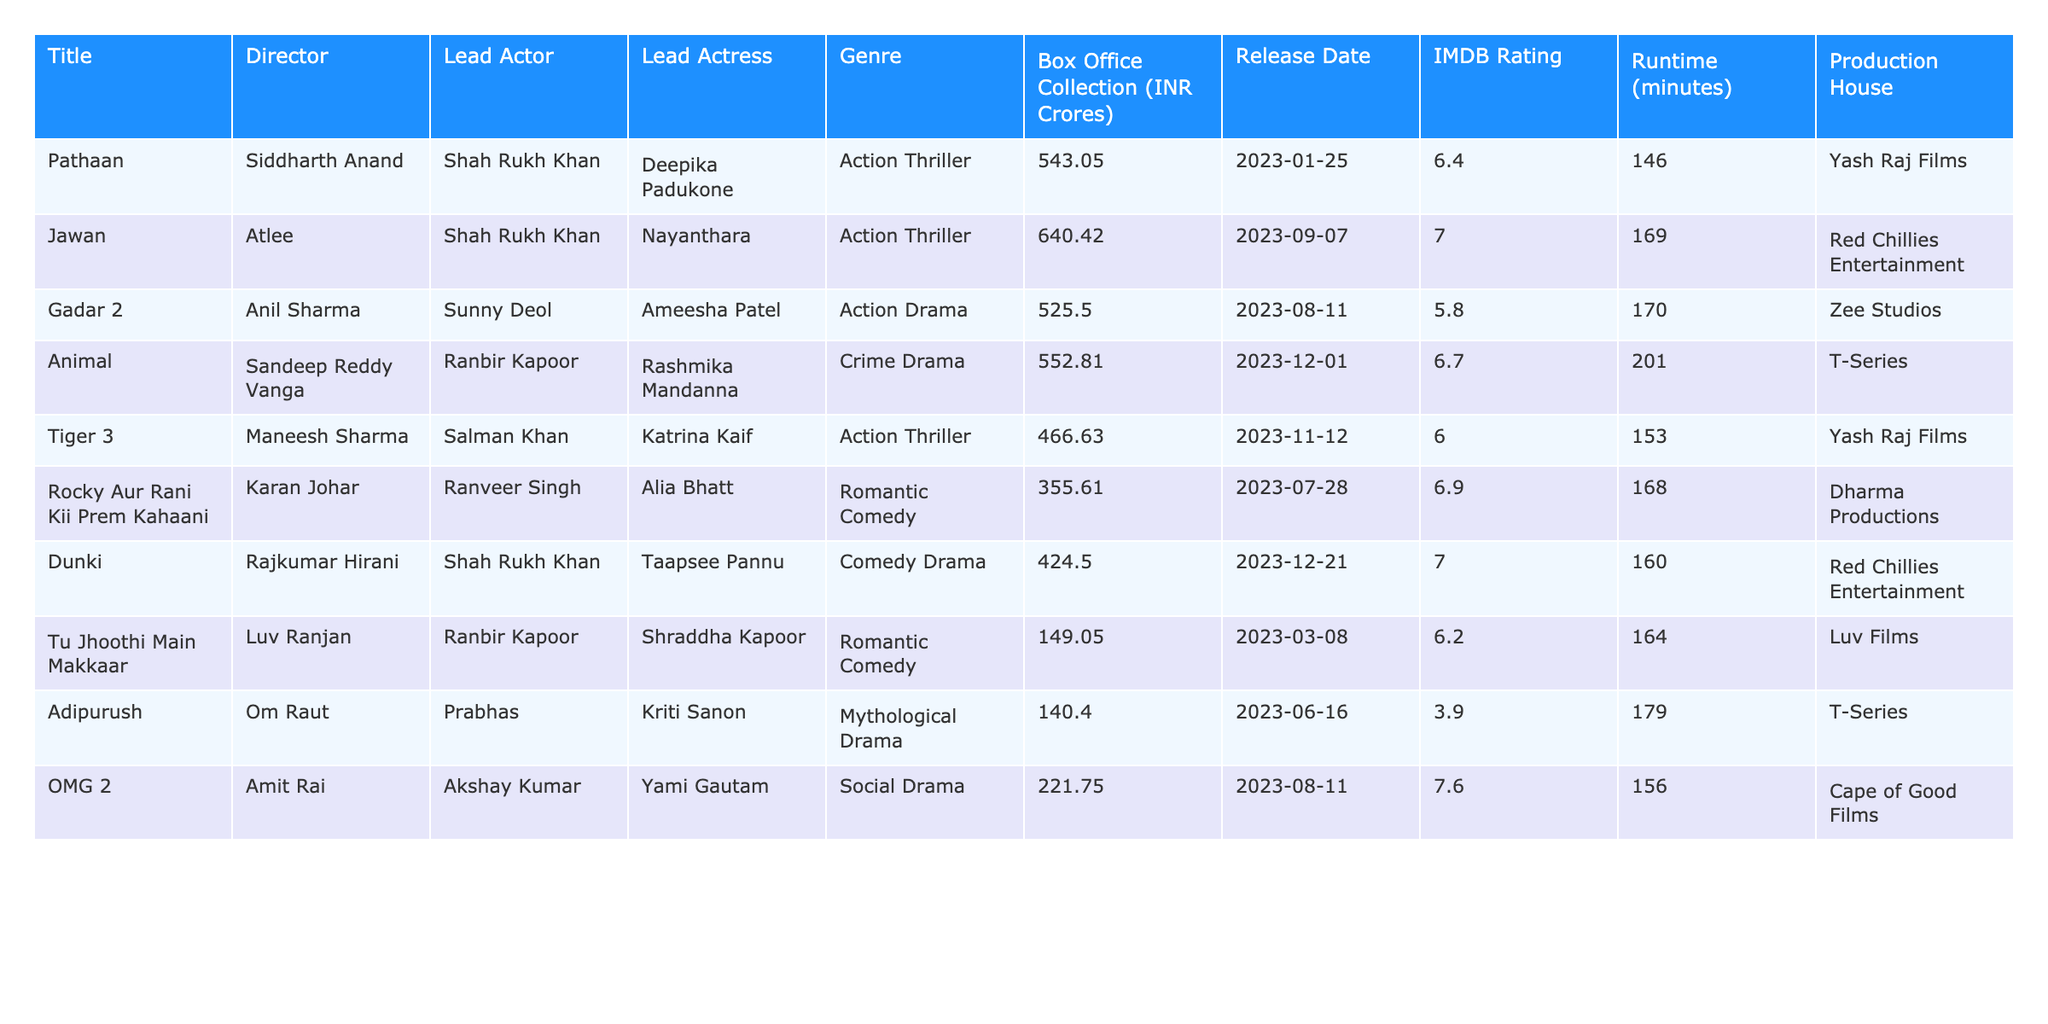What is the highest-grossing Bollywood film of the past year? The table shows "Jawan" as the film with the highest Box Office Collection of 640.42 INR Crores.
Answer: Jawan Which film features Shah Rukh Khan and Deepika Padukone? The film "Pathaan" features Shah Rukh Khan as the lead actor and Deepika Padukone as the lead actress.
Answer: Pathaan What is the IMDB rating of "Gadar 2"? The IMDB rating for "Gadar 2" is 5.8 as listed in the table.
Answer: 5.8 How many minutes long is "Animal"? The runtime for "Animal" is provided as 201 minutes.
Answer: 201 minutes Which production house produced "Tiger 3"? "Tiger 3" was produced by Yash Raj Films, as shown in the production house column.
Answer: Yash Raj Films What is the average Box Office Collection of the top 3 films? The top 3 films are "Jawan" (640.42), "Pathaan" (543.05), and "Gadar 2" (525.50). Their total is 640.42 + 543.05 + 525.50 = 1708.97, and the average is 1708.97/3 = 569.66.
Answer: 569.66 Did "OMG 2" perform better than "Adipurush" at the box office? Comparing the Box Office Collections shows "OMG 2" at 221.75 INR Crores and "Adipurush" at 140.40 INR Crores; hence, "OMG 2" performed better.
Answer: Yes Which film has the longest runtime and what is it? Comparing the runtimes in the table, "Animal" has the longest runtime at 201 minutes.
Answer: Animal, 201 minutes Is "Dunki" directed by Rajkumar Hirani? According to the table, "Dunki" is indeed directed by Rajkumar Hirani, so the statement is correct.
Answer: Yes Count how many different genres are represented in the top 10 films The films span 7 genres: Action Thriller, Action Drama, Crime Drama, Romantic Comedy, Comedy Drama, Mythological Drama, and Social Drama. Hence, the count is 7.
Answer: 7 